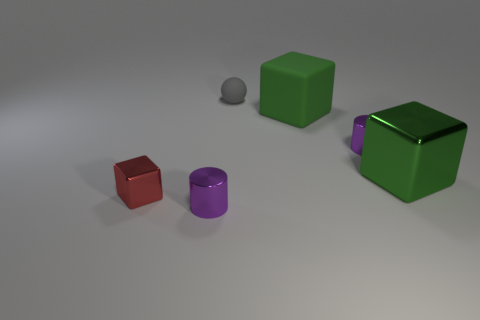Subtract all big metal cubes. How many cubes are left? 2 Subtract all red cubes. How many cubes are left? 2 Subtract 1 cubes. How many cubes are left? 2 Add 2 yellow cubes. How many objects exist? 8 Add 5 tiny purple metal objects. How many tiny purple metal objects are left? 7 Add 5 tiny metallic cubes. How many tiny metallic cubes exist? 6 Subtract 0 yellow balls. How many objects are left? 6 Subtract all cylinders. How many objects are left? 4 Subtract all blue cubes. Subtract all cyan spheres. How many cubes are left? 3 Subtract all blue cylinders. How many blue blocks are left? 0 